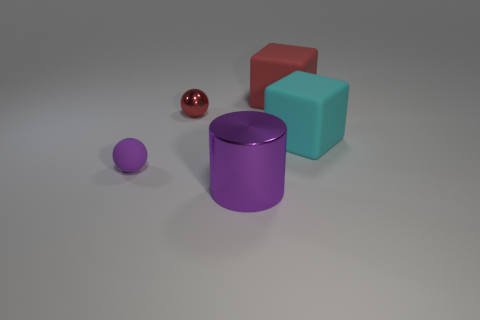Does the metallic thing that is on the left side of the big shiny thing have the same color as the rubber thing that is on the left side of the purple cylinder?
Offer a very short reply. No. Are there any red cubes that have the same material as the cylinder?
Your answer should be very brief. No. How many red things are cylinders or metal balls?
Keep it short and to the point. 1. Is the number of tiny rubber things that are behind the cyan object greater than the number of tiny objects?
Offer a very short reply. No. Is the size of the purple shiny cylinder the same as the cyan rubber block?
Your answer should be very brief. Yes. The tiny sphere that is the same material as the large red cube is what color?
Ensure brevity in your answer.  Purple. There is a matte thing that is the same color as the large metal cylinder; what is its shape?
Keep it short and to the point. Sphere. Are there an equal number of large red rubber blocks that are to the left of the purple sphere and matte blocks that are on the left side of the large metallic cylinder?
Your answer should be compact. Yes. What shape is the thing behind the tiny ball to the right of the tiny purple sphere?
Provide a short and direct response. Cube. What material is the cyan object that is the same shape as the red matte object?
Provide a short and direct response. Rubber. 